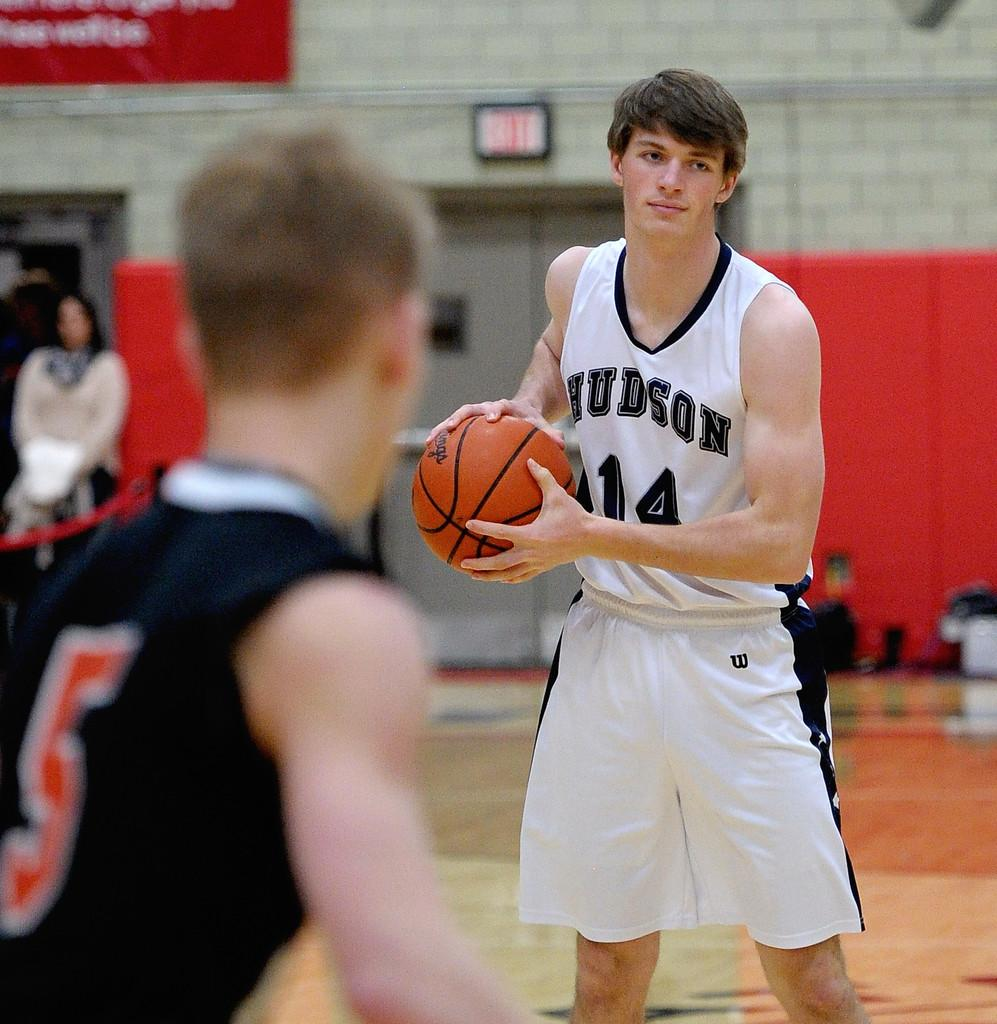<image>
Write a terse but informative summary of the picture. The player for Hudson with the number 14 on his jersey has the ball. 